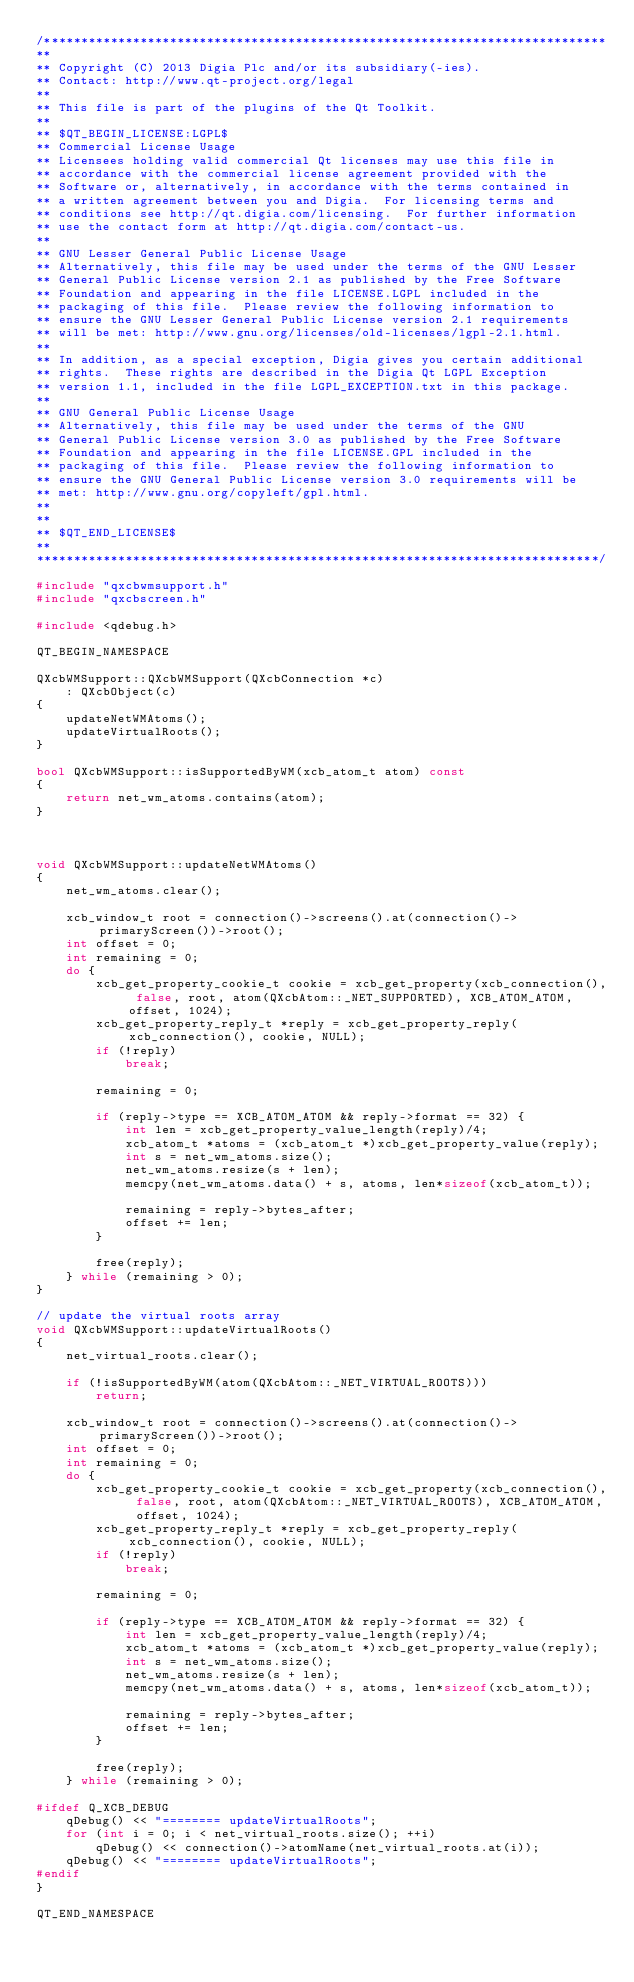Convert code to text. <code><loc_0><loc_0><loc_500><loc_500><_C++_>/****************************************************************************
**
** Copyright (C) 2013 Digia Plc and/or its subsidiary(-ies).
** Contact: http://www.qt-project.org/legal
**
** This file is part of the plugins of the Qt Toolkit.
**
** $QT_BEGIN_LICENSE:LGPL$
** Commercial License Usage
** Licensees holding valid commercial Qt licenses may use this file in
** accordance with the commercial license agreement provided with the
** Software or, alternatively, in accordance with the terms contained in
** a written agreement between you and Digia.  For licensing terms and
** conditions see http://qt.digia.com/licensing.  For further information
** use the contact form at http://qt.digia.com/contact-us.
**
** GNU Lesser General Public License Usage
** Alternatively, this file may be used under the terms of the GNU Lesser
** General Public License version 2.1 as published by the Free Software
** Foundation and appearing in the file LICENSE.LGPL included in the
** packaging of this file.  Please review the following information to
** ensure the GNU Lesser General Public License version 2.1 requirements
** will be met: http://www.gnu.org/licenses/old-licenses/lgpl-2.1.html.
**
** In addition, as a special exception, Digia gives you certain additional
** rights.  These rights are described in the Digia Qt LGPL Exception
** version 1.1, included in the file LGPL_EXCEPTION.txt in this package.
**
** GNU General Public License Usage
** Alternatively, this file may be used under the terms of the GNU
** General Public License version 3.0 as published by the Free Software
** Foundation and appearing in the file LICENSE.GPL included in the
** packaging of this file.  Please review the following information to
** ensure the GNU General Public License version 3.0 requirements will be
** met: http://www.gnu.org/copyleft/gpl.html.
**
**
** $QT_END_LICENSE$
**
****************************************************************************/

#include "qxcbwmsupport.h"
#include "qxcbscreen.h"

#include <qdebug.h>

QT_BEGIN_NAMESPACE

QXcbWMSupport::QXcbWMSupport(QXcbConnection *c)
    : QXcbObject(c)
{
    updateNetWMAtoms();
    updateVirtualRoots();
}

bool QXcbWMSupport::isSupportedByWM(xcb_atom_t atom) const
{
    return net_wm_atoms.contains(atom);
}



void QXcbWMSupport::updateNetWMAtoms()
{
    net_wm_atoms.clear();

    xcb_window_t root = connection()->screens().at(connection()->primaryScreen())->root();
    int offset = 0;
    int remaining = 0;
    do {
        xcb_get_property_cookie_t cookie = xcb_get_property(xcb_connection(), false, root, atom(QXcbAtom::_NET_SUPPORTED), XCB_ATOM_ATOM, offset, 1024);
        xcb_get_property_reply_t *reply = xcb_get_property_reply(xcb_connection(), cookie, NULL);
        if (!reply)
            break;

        remaining = 0;

        if (reply->type == XCB_ATOM_ATOM && reply->format == 32) {
            int len = xcb_get_property_value_length(reply)/4;
            xcb_atom_t *atoms = (xcb_atom_t *)xcb_get_property_value(reply);
            int s = net_wm_atoms.size();
            net_wm_atoms.resize(s + len);
            memcpy(net_wm_atoms.data() + s, atoms, len*sizeof(xcb_atom_t));

            remaining = reply->bytes_after;
            offset += len;
        }

        free(reply);
    } while (remaining > 0);
}

// update the virtual roots array
void QXcbWMSupport::updateVirtualRoots()
{
    net_virtual_roots.clear();

    if (!isSupportedByWM(atom(QXcbAtom::_NET_VIRTUAL_ROOTS)))
        return;

    xcb_window_t root = connection()->screens().at(connection()->primaryScreen())->root();
    int offset = 0;
    int remaining = 0;
    do {
        xcb_get_property_cookie_t cookie = xcb_get_property(xcb_connection(), false, root, atom(QXcbAtom::_NET_VIRTUAL_ROOTS), XCB_ATOM_ATOM, offset, 1024);
        xcb_get_property_reply_t *reply = xcb_get_property_reply(xcb_connection(), cookie, NULL);
        if (!reply)
            break;

        remaining = 0;

        if (reply->type == XCB_ATOM_ATOM && reply->format == 32) {
            int len = xcb_get_property_value_length(reply)/4;
            xcb_atom_t *atoms = (xcb_atom_t *)xcb_get_property_value(reply);
            int s = net_wm_atoms.size();
            net_wm_atoms.resize(s + len);
            memcpy(net_wm_atoms.data() + s, atoms, len*sizeof(xcb_atom_t));

            remaining = reply->bytes_after;
            offset += len;
        }

        free(reply);
    } while (remaining > 0);

#ifdef Q_XCB_DEBUG
    qDebug() << "======== updateVirtualRoots";
    for (int i = 0; i < net_virtual_roots.size(); ++i)
        qDebug() << connection()->atomName(net_virtual_roots.at(i));
    qDebug() << "======== updateVirtualRoots";
#endif
}

QT_END_NAMESPACE
</code> 